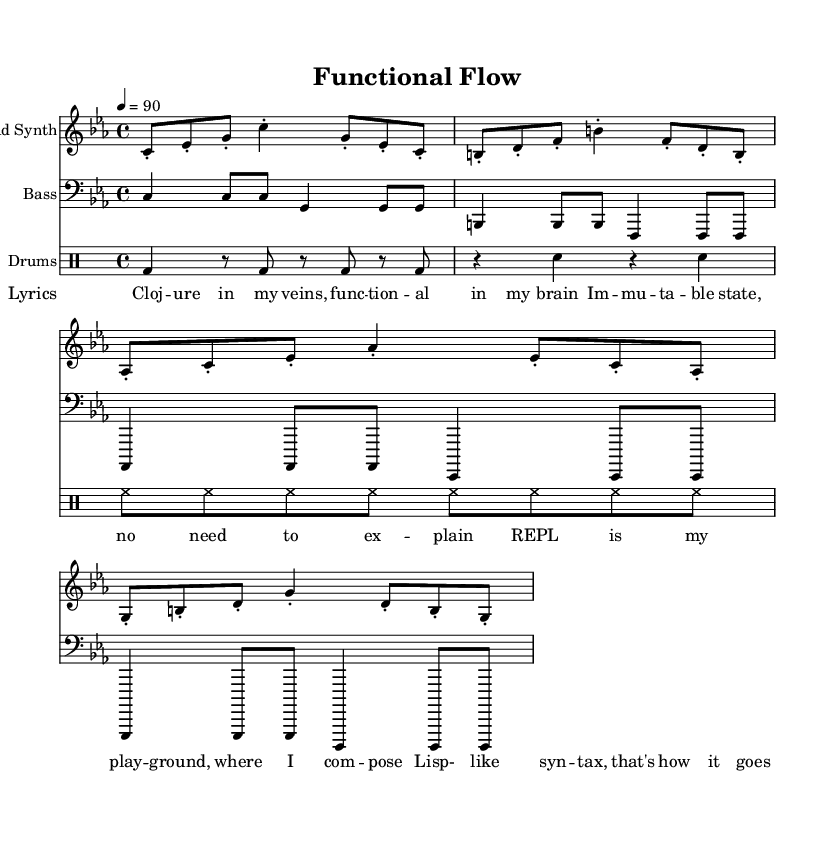What is the key signature of this music? The key signature shown in the global section of the sheet music indicates C minor, which has three flats in its scale.
Answer: C minor What is the time signature of this music? The time signature, also specified in the global section, is indicated as 4/4, meaning there are four beats in each measure and the quarter note gets one beat.
Answer: 4/4 What is the tempo marking for this piece? The tempo marking in the global section indicates a tempo of 90 beats per minute, which sets the pace for how fast the music should be played.
Answer: 90 How many different instruments are featured in this piece? In the score section, there are three distinct staves, which represent the lead synth, bass, and drums, showing that there are three different instruments.
Answer: 3 What lyrical theme is represented in the song? The lyrics focus on programming concepts, mentioning terms like "Clojure," "REPL," and "immutable," all of which are tied to programming and functional programming principles.
Answer: Programming What type of musical structure is employed in this piece? The structure includes a combination of lyrical content paired with instrumental backing, typical of hip hop tracks, which often integrate vocal rap with rhythmic instrumentation.
Answer: Lyrical and instrumental 